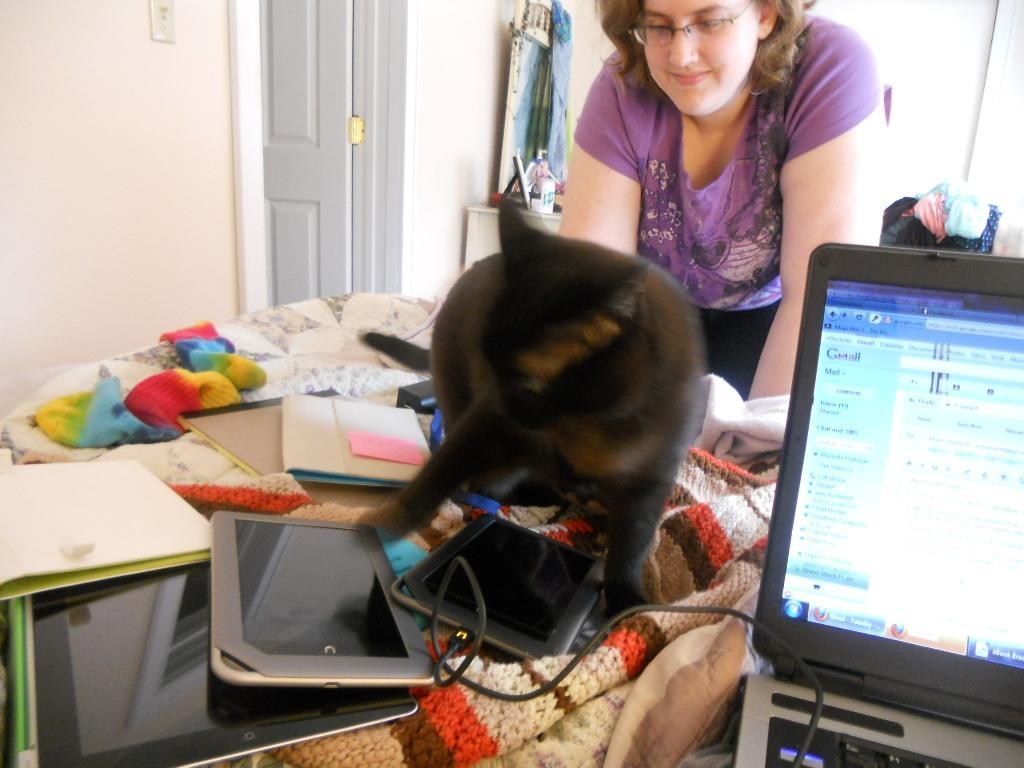Please provide a concise description of this image. In the center of the image there is a table on which there are books, electronic devices. There is a black color animal. There is a lady standing. To the right side of the image there is a laptop. In the background of the image there is wall. There is a door. There are objects. There are clothes. 